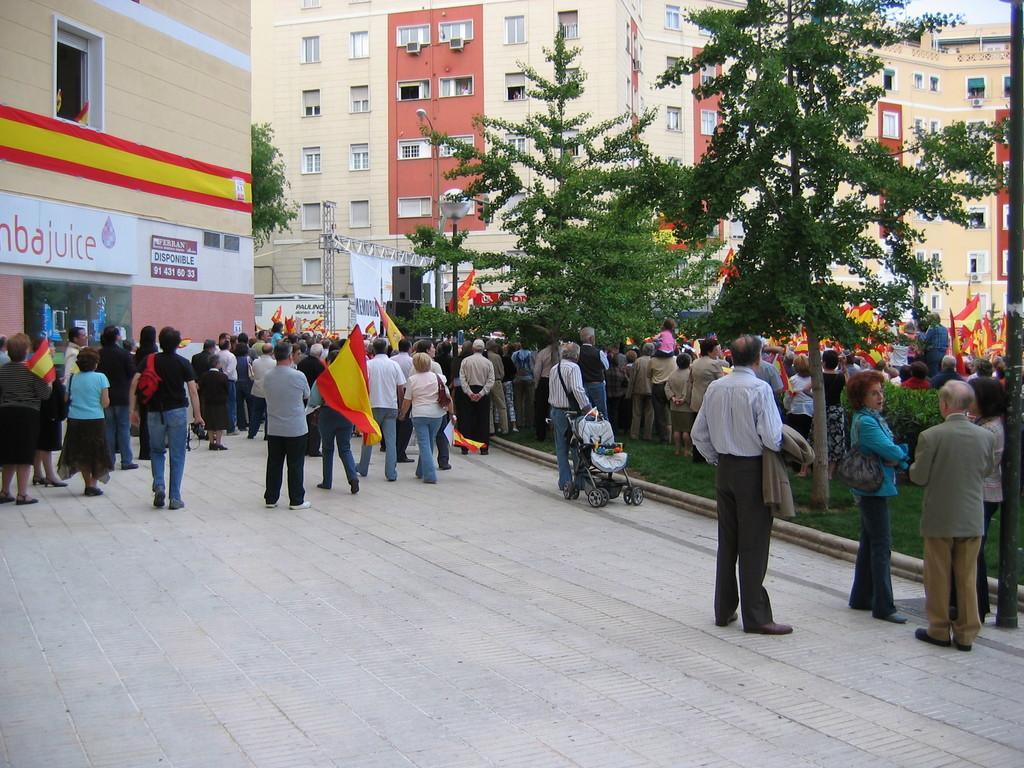Please provide a concise description of this image. In this picture I can see the path and the grass, on which there are number of people who are standing and I see that few of them are holding flags and I see number of trees and plants. In the background I can see number of buildings. On the left side of this image I see a board on which there is something written. 